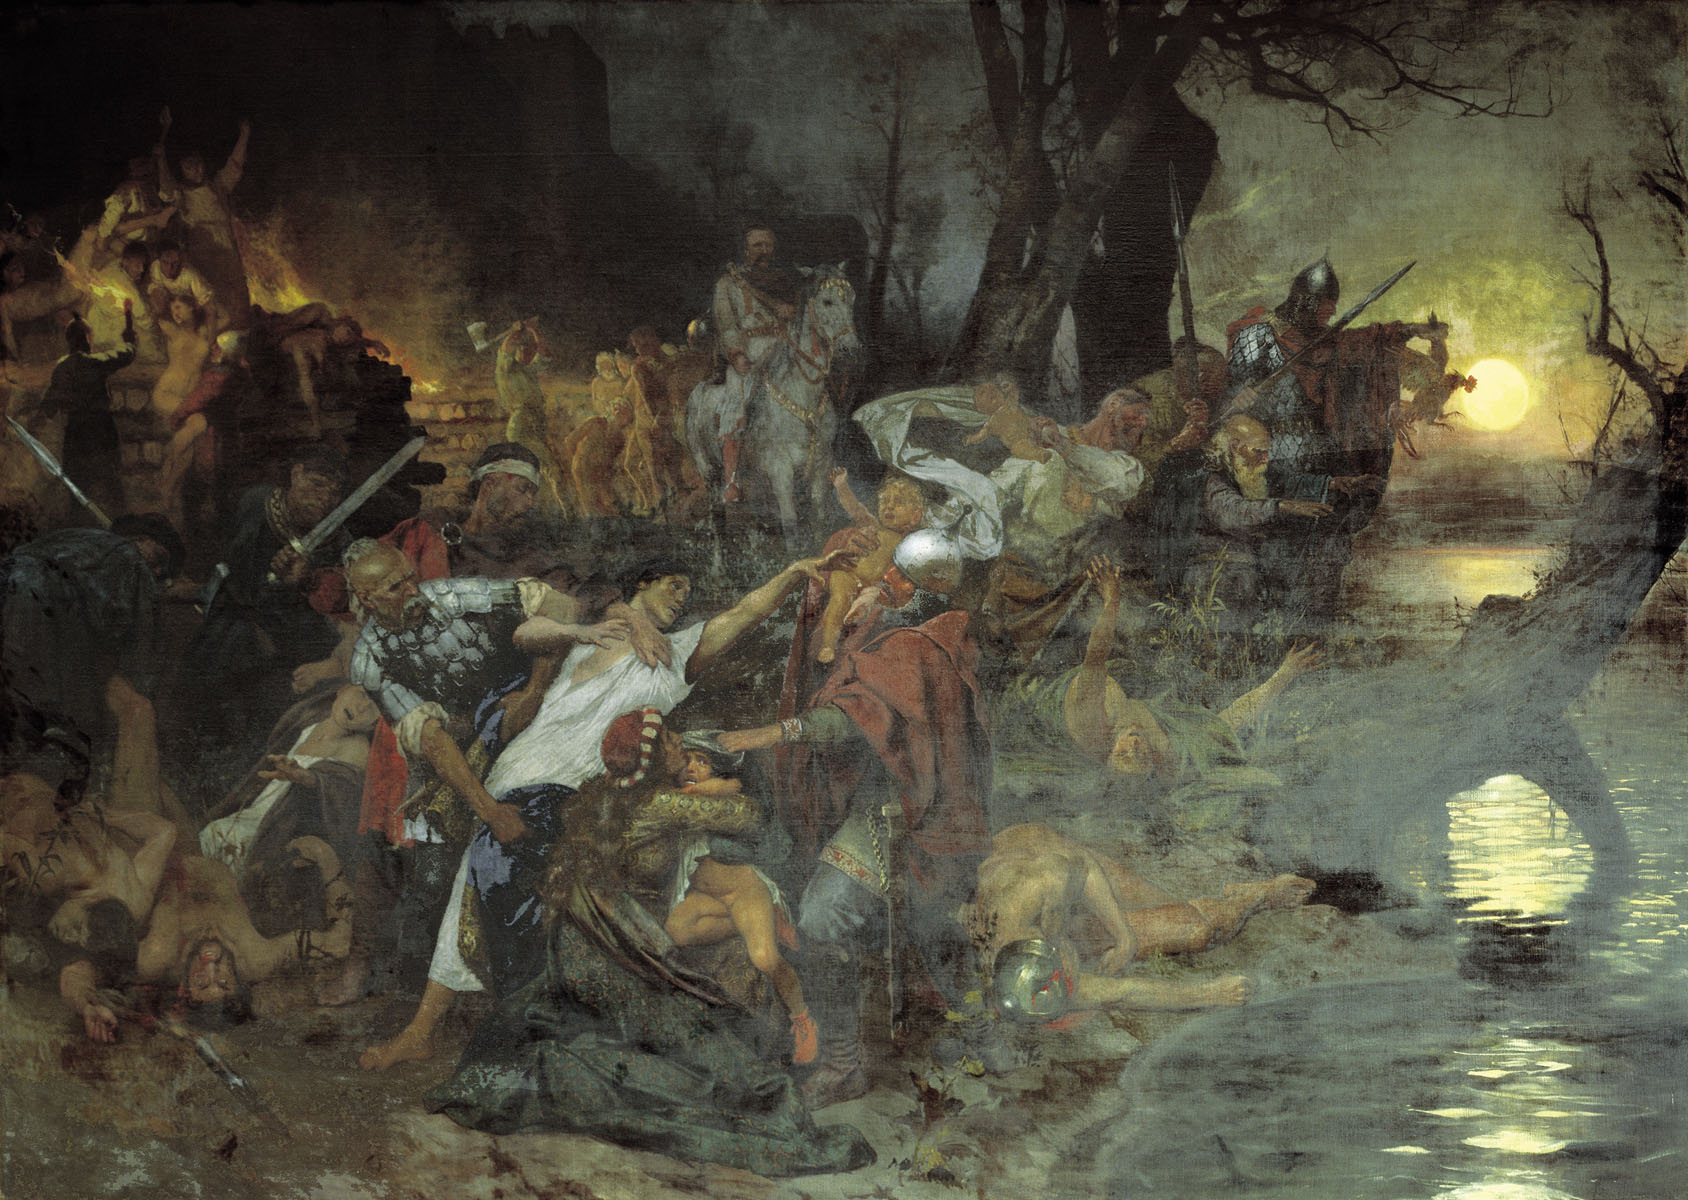Write a fictional backstory for one of the figures in the image. Sir Edric of Raelth, the knight in the foreground with a determined expression, once belonged to a peaceful and prosperous village. His life was upended when a rival lord attacked his homeland, motivated by greed and the desire for power. Watching his village burn, powerless to prevent the slaughter of his friends and family, filled Edric with a burning resolve for justice. Surviving the initial onslaught, he trained relentlessly and joined forces with others who had suffered similar fates. This battle in the swamp represents his final stand, where he fights not just for survival but for the memory of his lost loved ones, driven by a hope to reclaim peace and honor once more. How might future historians interpret this painting if it were discovered centuries later? Centuries later, historians might interpret this painting as a vivid representation of the horrors and chaos of historical warfare. They might see it as a reflection of the artist’s perspective on the futility and devastation of conflict. The emotional intensity captured by the figures might be studied to understand the human cost of war during this era. Future scholars might also analyze the painting's style, color use, and composition as examples of Romanticism or another significant art movement, uncovering insights into the cultural and historical context of the time when the artist lived and worked. 